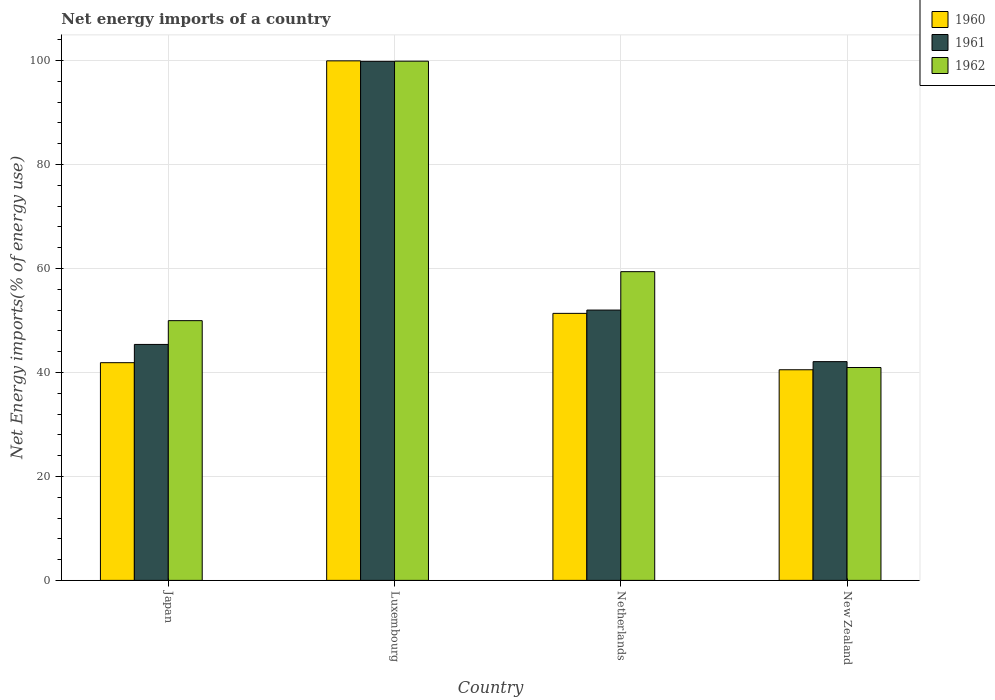How many groups of bars are there?
Ensure brevity in your answer.  4. Are the number of bars per tick equal to the number of legend labels?
Offer a terse response. Yes. Are the number of bars on each tick of the X-axis equal?
Provide a short and direct response. Yes. What is the label of the 4th group of bars from the left?
Offer a terse response. New Zealand. In how many cases, is the number of bars for a given country not equal to the number of legend labels?
Offer a terse response. 0. What is the net energy imports in 1960 in New Zealand?
Your answer should be very brief. 40.52. Across all countries, what is the maximum net energy imports in 1961?
Ensure brevity in your answer.  99.85. Across all countries, what is the minimum net energy imports in 1961?
Give a very brief answer. 42.08. In which country was the net energy imports in 1962 maximum?
Make the answer very short. Luxembourg. In which country was the net energy imports in 1960 minimum?
Ensure brevity in your answer.  New Zealand. What is the total net energy imports in 1962 in the graph?
Ensure brevity in your answer.  250.2. What is the difference between the net energy imports in 1962 in Japan and that in Luxembourg?
Your answer should be compact. -49.92. What is the difference between the net energy imports in 1962 in Netherlands and the net energy imports in 1960 in Luxembourg?
Keep it short and to the point. -40.56. What is the average net energy imports in 1961 per country?
Ensure brevity in your answer.  59.83. What is the difference between the net energy imports of/in 1961 and net energy imports of/in 1962 in Japan?
Offer a terse response. -4.57. In how many countries, is the net energy imports in 1960 greater than 20 %?
Provide a short and direct response. 4. What is the ratio of the net energy imports in 1962 in Luxembourg to that in Netherlands?
Your answer should be compact. 1.68. What is the difference between the highest and the second highest net energy imports in 1962?
Offer a very short reply. -40.49. What is the difference between the highest and the lowest net energy imports in 1962?
Offer a terse response. 58.93. Is the sum of the net energy imports in 1961 in Japan and New Zealand greater than the maximum net energy imports in 1960 across all countries?
Make the answer very short. No. What does the 1st bar from the left in Netherlands represents?
Your answer should be compact. 1960. Are all the bars in the graph horizontal?
Offer a terse response. No. What is the difference between two consecutive major ticks on the Y-axis?
Your answer should be compact. 20. Are the values on the major ticks of Y-axis written in scientific E-notation?
Offer a terse response. No. Does the graph contain grids?
Your response must be concise. Yes. What is the title of the graph?
Offer a terse response. Net energy imports of a country. What is the label or title of the Y-axis?
Provide a succinct answer. Net Energy imports(% of energy use). What is the Net Energy imports(% of energy use) of 1960 in Japan?
Offer a terse response. 41.88. What is the Net Energy imports(% of energy use) in 1961 in Japan?
Offer a very short reply. 45.39. What is the Net Energy imports(% of energy use) in 1962 in Japan?
Ensure brevity in your answer.  49.97. What is the Net Energy imports(% of energy use) in 1960 in Luxembourg?
Ensure brevity in your answer.  99.95. What is the Net Energy imports(% of energy use) of 1961 in Luxembourg?
Give a very brief answer. 99.85. What is the Net Energy imports(% of energy use) in 1962 in Luxembourg?
Offer a terse response. 99.88. What is the Net Energy imports(% of energy use) of 1960 in Netherlands?
Give a very brief answer. 51.37. What is the Net Energy imports(% of energy use) in 1961 in Netherlands?
Provide a short and direct response. 52. What is the Net Energy imports(% of energy use) of 1962 in Netherlands?
Your response must be concise. 59.39. What is the Net Energy imports(% of energy use) of 1960 in New Zealand?
Offer a very short reply. 40.52. What is the Net Energy imports(% of energy use) in 1961 in New Zealand?
Offer a very short reply. 42.08. What is the Net Energy imports(% of energy use) of 1962 in New Zealand?
Your answer should be very brief. 40.95. Across all countries, what is the maximum Net Energy imports(% of energy use) in 1960?
Your answer should be compact. 99.95. Across all countries, what is the maximum Net Energy imports(% of energy use) in 1961?
Your answer should be very brief. 99.85. Across all countries, what is the maximum Net Energy imports(% of energy use) in 1962?
Provide a short and direct response. 99.88. Across all countries, what is the minimum Net Energy imports(% of energy use) in 1960?
Keep it short and to the point. 40.52. Across all countries, what is the minimum Net Energy imports(% of energy use) of 1961?
Your answer should be very brief. 42.08. Across all countries, what is the minimum Net Energy imports(% of energy use) of 1962?
Ensure brevity in your answer.  40.95. What is the total Net Energy imports(% of energy use) in 1960 in the graph?
Make the answer very short. 233.72. What is the total Net Energy imports(% of energy use) in 1961 in the graph?
Offer a very short reply. 239.34. What is the total Net Energy imports(% of energy use) in 1962 in the graph?
Your response must be concise. 250.2. What is the difference between the Net Energy imports(% of energy use) of 1960 in Japan and that in Luxembourg?
Make the answer very short. -58.07. What is the difference between the Net Energy imports(% of energy use) of 1961 in Japan and that in Luxembourg?
Offer a very short reply. -54.46. What is the difference between the Net Energy imports(% of energy use) of 1962 in Japan and that in Luxembourg?
Your answer should be very brief. -49.92. What is the difference between the Net Energy imports(% of energy use) of 1960 in Japan and that in Netherlands?
Provide a succinct answer. -9.49. What is the difference between the Net Energy imports(% of energy use) of 1961 in Japan and that in Netherlands?
Provide a succinct answer. -6.61. What is the difference between the Net Energy imports(% of energy use) in 1962 in Japan and that in Netherlands?
Provide a short and direct response. -9.42. What is the difference between the Net Energy imports(% of energy use) in 1960 in Japan and that in New Zealand?
Ensure brevity in your answer.  1.36. What is the difference between the Net Energy imports(% of energy use) in 1961 in Japan and that in New Zealand?
Offer a terse response. 3.31. What is the difference between the Net Energy imports(% of energy use) in 1962 in Japan and that in New Zealand?
Provide a short and direct response. 9.02. What is the difference between the Net Energy imports(% of energy use) in 1960 in Luxembourg and that in Netherlands?
Make the answer very short. 48.58. What is the difference between the Net Energy imports(% of energy use) in 1961 in Luxembourg and that in Netherlands?
Your answer should be compact. 47.85. What is the difference between the Net Energy imports(% of energy use) of 1962 in Luxembourg and that in Netherlands?
Provide a short and direct response. 40.49. What is the difference between the Net Energy imports(% of energy use) of 1960 in Luxembourg and that in New Zealand?
Offer a terse response. 59.43. What is the difference between the Net Energy imports(% of energy use) of 1961 in Luxembourg and that in New Zealand?
Give a very brief answer. 57.77. What is the difference between the Net Energy imports(% of energy use) in 1962 in Luxembourg and that in New Zealand?
Provide a short and direct response. 58.93. What is the difference between the Net Energy imports(% of energy use) of 1960 in Netherlands and that in New Zealand?
Your answer should be very brief. 10.85. What is the difference between the Net Energy imports(% of energy use) in 1961 in Netherlands and that in New Zealand?
Offer a very short reply. 9.92. What is the difference between the Net Energy imports(% of energy use) of 1962 in Netherlands and that in New Zealand?
Your response must be concise. 18.44. What is the difference between the Net Energy imports(% of energy use) of 1960 in Japan and the Net Energy imports(% of energy use) of 1961 in Luxembourg?
Offer a terse response. -57.97. What is the difference between the Net Energy imports(% of energy use) in 1960 in Japan and the Net Energy imports(% of energy use) in 1962 in Luxembourg?
Offer a very short reply. -58. What is the difference between the Net Energy imports(% of energy use) of 1961 in Japan and the Net Energy imports(% of energy use) of 1962 in Luxembourg?
Keep it short and to the point. -54.49. What is the difference between the Net Energy imports(% of energy use) in 1960 in Japan and the Net Energy imports(% of energy use) in 1961 in Netherlands?
Keep it short and to the point. -10.12. What is the difference between the Net Energy imports(% of energy use) in 1960 in Japan and the Net Energy imports(% of energy use) in 1962 in Netherlands?
Your answer should be compact. -17.51. What is the difference between the Net Energy imports(% of energy use) of 1961 in Japan and the Net Energy imports(% of energy use) of 1962 in Netherlands?
Your answer should be compact. -14. What is the difference between the Net Energy imports(% of energy use) of 1960 in Japan and the Net Energy imports(% of energy use) of 1961 in New Zealand?
Your answer should be compact. -0.2. What is the difference between the Net Energy imports(% of energy use) of 1960 in Japan and the Net Energy imports(% of energy use) of 1962 in New Zealand?
Ensure brevity in your answer.  0.93. What is the difference between the Net Energy imports(% of energy use) of 1961 in Japan and the Net Energy imports(% of energy use) of 1962 in New Zealand?
Ensure brevity in your answer.  4.44. What is the difference between the Net Energy imports(% of energy use) of 1960 in Luxembourg and the Net Energy imports(% of energy use) of 1961 in Netherlands?
Provide a succinct answer. 47.94. What is the difference between the Net Energy imports(% of energy use) in 1960 in Luxembourg and the Net Energy imports(% of energy use) in 1962 in Netherlands?
Ensure brevity in your answer.  40.56. What is the difference between the Net Energy imports(% of energy use) in 1961 in Luxembourg and the Net Energy imports(% of energy use) in 1962 in Netherlands?
Provide a succinct answer. 40.46. What is the difference between the Net Energy imports(% of energy use) in 1960 in Luxembourg and the Net Energy imports(% of energy use) in 1961 in New Zealand?
Make the answer very short. 57.87. What is the difference between the Net Energy imports(% of energy use) of 1960 in Luxembourg and the Net Energy imports(% of energy use) of 1962 in New Zealand?
Provide a short and direct response. 58.99. What is the difference between the Net Energy imports(% of energy use) of 1961 in Luxembourg and the Net Energy imports(% of energy use) of 1962 in New Zealand?
Your answer should be very brief. 58.9. What is the difference between the Net Energy imports(% of energy use) in 1960 in Netherlands and the Net Energy imports(% of energy use) in 1961 in New Zealand?
Make the answer very short. 9.29. What is the difference between the Net Energy imports(% of energy use) in 1960 in Netherlands and the Net Energy imports(% of energy use) in 1962 in New Zealand?
Provide a short and direct response. 10.42. What is the difference between the Net Energy imports(% of energy use) in 1961 in Netherlands and the Net Energy imports(% of energy use) in 1962 in New Zealand?
Provide a succinct answer. 11.05. What is the average Net Energy imports(% of energy use) in 1960 per country?
Your response must be concise. 58.43. What is the average Net Energy imports(% of energy use) in 1961 per country?
Keep it short and to the point. 59.83. What is the average Net Energy imports(% of energy use) in 1962 per country?
Ensure brevity in your answer.  62.55. What is the difference between the Net Energy imports(% of energy use) of 1960 and Net Energy imports(% of energy use) of 1961 in Japan?
Your answer should be very brief. -3.51. What is the difference between the Net Energy imports(% of energy use) in 1960 and Net Energy imports(% of energy use) in 1962 in Japan?
Provide a succinct answer. -8.09. What is the difference between the Net Energy imports(% of energy use) in 1961 and Net Energy imports(% of energy use) in 1962 in Japan?
Give a very brief answer. -4.57. What is the difference between the Net Energy imports(% of energy use) in 1960 and Net Energy imports(% of energy use) in 1961 in Luxembourg?
Your answer should be very brief. 0.09. What is the difference between the Net Energy imports(% of energy use) in 1960 and Net Energy imports(% of energy use) in 1962 in Luxembourg?
Your answer should be compact. 0.06. What is the difference between the Net Energy imports(% of energy use) in 1961 and Net Energy imports(% of energy use) in 1962 in Luxembourg?
Your response must be concise. -0.03. What is the difference between the Net Energy imports(% of energy use) of 1960 and Net Energy imports(% of energy use) of 1961 in Netherlands?
Your answer should be compact. -0.64. What is the difference between the Net Energy imports(% of energy use) in 1960 and Net Energy imports(% of energy use) in 1962 in Netherlands?
Keep it short and to the point. -8.02. What is the difference between the Net Energy imports(% of energy use) of 1961 and Net Energy imports(% of energy use) of 1962 in Netherlands?
Make the answer very short. -7.39. What is the difference between the Net Energy imports(% of energy use) in 1960 and Net Energy imports(% of energy use) in 1961 in New Zealand?
Give a very brief answer. -1.56. What is the difference between the Net Energy imports(% of energy use) in 1960 and Net Energy imports(% of energy use) in 1962 in New Zealand?
Provide a short and direct response. -0.43. What is the difference between the Net Energy imports(% of energy use) in 1961 and Net Energy imports(% of energy use) in 1962 in New Zealand?
Your response must be concise. 1.13. What is the ratio of the Net Energy imports(% of energy use) of 1960 in Japan to that in Luxembourg?
Offer a very short reply. 0.42. What is the ratio of the Net Energy imports(% of energy use) in 1961 in Japan to that in Luxembourg?
Make the answer very short. 0.45. What is the ratio of the Net Energy imports(% of energy use) of 1962 in Japan to that in Luxembourg?
Provide a succinct answer. 0.5. What is the ratio of the Net Energy imports(% of energy use) in 1960 in Japan to that in Netherlands?
Your answer should be very brief. 0.82. What is the ratio of the Net Energy imports(% of energy use) of 1961 in Japan to that in Netherlands?
Your answer should be very brief. 0.87. What is the ratio of the Net Energy imports(% of energy use) in 1962 in Japan to that in Netherlands?
Your answer should be compact. 0.84. What is the ratio of the Net Energy imports(% of energy use) in 1960 in Japan to that in New Zealand?
Your answer should be very brief. 1.03. What is the ratio of the Net Energy imports(% of energy use) in 1961 in Japan to that in New Zealand?
Provide a short and direct response. 1.08. What is the ratio of the Net Energy imports(% of energy use) in 1962 in Japan to that in New Zealand?
Give a very brief answer. 1.22. What is the ratio of the Net Energy imports(% of energy use) of 1960 in Luxembourg to that in Netherlands?
Provide a short and direct response. 1.95. What is the ratio of the Net Energy imports(% of energy use) in 1961 in Luxembourg to that in Netherlands?
Provide a short and direct response. 1.92. What is the ratio of the Net Energy imports(% of energy use) in 1962 in Luxembourg to that in Netherlands?
Offer a terse response. 1.68. What is the ratio of the Net Energy imports(% of energy use) of 1960 in Luxembourg to that in New Zealand?
Your answer should be very brief. 2.47. What is the ratio of the Net Energy imports(% of energy use) in 1961 in Luxembourg to that in New Zealand?
Make the answer very short. 2.37. What is the ratio of the Net Energy imports(% of energy use) in 1962 in Luxembourg to that in New Zealand?
Offer a very short reply. 2.44. What is the ratio of the Net Energy imports(% of energy use) in 1960 in Netherlands to that in New Zealand?
Ensure brevity in your answer.  1.27. What is the ratio of the Net Energy imports(% of energy use) in 1961 in Netherlands to that in New Zealand?
Your answer should be compact. 1.24. What is the ratio of the Net Energy imports(% of energy use) in 1962 in Netherlands to that in New Zealand?
Your answer should be very brief. 1.45. What is the difference between the highest and the second highest Net Energy imports(% of energy use) of 1960?
Your response must be concise. 48.58. What is the difference between the highest and the second highest Net Energy imports(% of energy use) in 1961?
Offer a very short reply. 47.85. What is the difference between the highest and the second highest Net Energy imports(% of energy use) of 1962?
Your answer should be compact. 40.49. What is the difference between the highest and the lowest Net Energy imports(% of energy use) of 1960?
Provide a succinct answer. 59.43. What is the difference between the highest and the lowest Net Energy imports(% of energy use) in 1961?
Provide a short and direct response. 57.77. What is the difference between the highest and the lowest Net Energy imports(% of energy use) of 1962?
Keep it short and to the point. 58.93. 